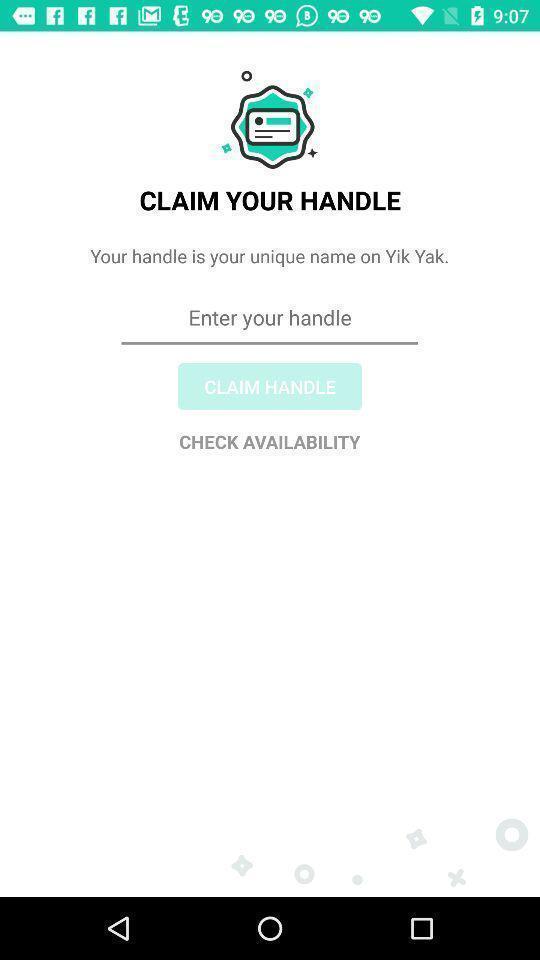What can you discern from this picture? Page showing the field to enter the unique name. 